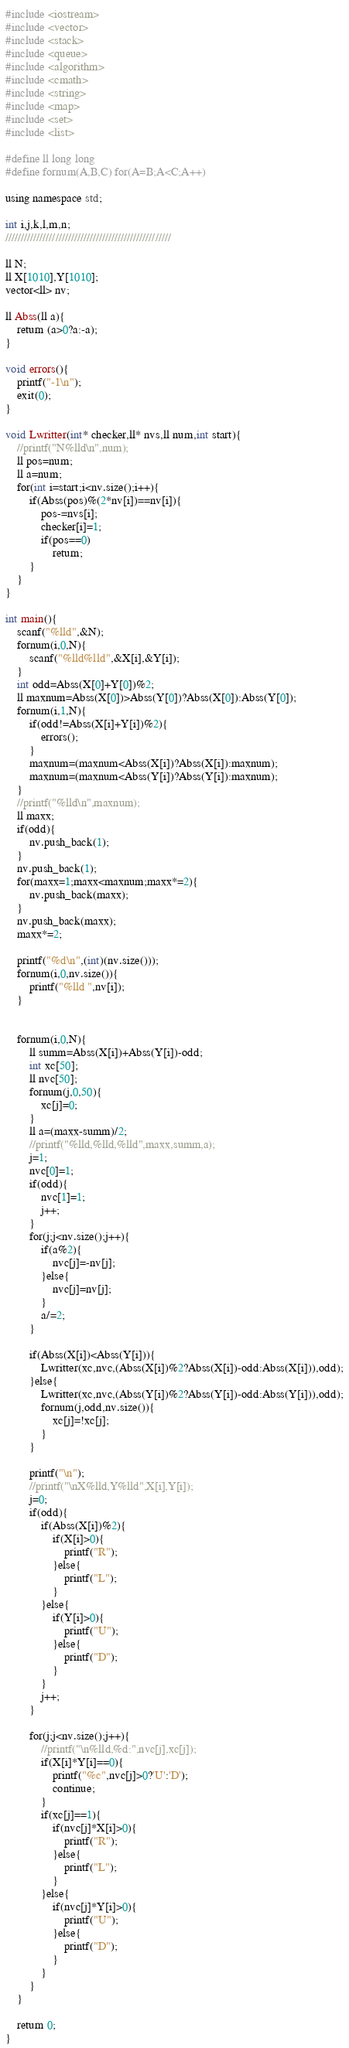<code> <loc_0><loc_0><loc_500><loc_500><_C++_>#include <iostream>
#include <vector>
#include <stack>
#include <queue>
#include <algorithm>
#include <cmath>
#include <string>
#include <map>
#include <set>
#include <list>

#define ll long long
#define fornum(A,B,C) for(A=B;A<C;A++)

using namespace std;

int i,j,k,l,m,n;
/////////////////////////////////////////////////////

ll N;
ll X[1010],Y[1010];
vector<ll> nv;

ll Abss(ll a){
    return (a>0?a:-a);
}

void errors(){
    printf("-1\n");
    exit(0);
}

void Lwritter(int* checker,ll* nvs,ll num,int start){
    //printf("N%lld\n",num);
    ll pos=num;
    ll a=num;
    for(int i=start;i<nv.size();i++){
        if(Abss(pos)%(2*nv[i])==nv[i]){
            pos-=nvs[i];
            checker[i]=1;
            if(pos==0)
                return;
        }
    }
}

int main(){
    scanf("%lld",&N);
    fornum(i,0,N){
        scanf("%lld%lld",&X[i],&Y[i]);
    }
    int odd=Abss(X[0]+Y[0])%2;
    ll maxnum=Abss(X[0])>Abss(Y[0])?Abss(X[0]):Abss(Y[0]);
    fornum(i,1,N){
        if(odd!=Abss(X[i]+Y[i])%2){
            errors();
        }
        maxnum=(maxnum<Abss(X[i])?Abss(X[i]):maxnum);
        maxnum=(maxnum<Abss(Y[i])?Abss(Y[i]):maxnum);
    }
    //printf("%lld\n",maxnum);
    ll maxx;
    if(odd){
        nv.push_back(1);
    }
    nv.push_back(1);
    for(maxx=1;maxx<maxnum;maxx*=2){
        nv.push_back(maxx);
    }
    nv.push_back(maxx);
    maxx*=2;

    printf("%d\n",(int)(nv.size()));
    fornum(i,0,nv.size()){
        printf("%lld ",nv[i]);
    }
    

    fornum(i,0,N){
        ll summ=Abss(X[i])+Abss(Y[i])-odd;
        int xc[50];
        ll nvc[50];
        fornum(j,0,50){
            xc[j]=0;
        }
        ll a=(maxx-summ)/2;
        //printf("%lld,%lld,%lld",maxx,summ,a);
        j=1;
        nvc[0]=1;
        if(odd){
            nvc[1]=1;
            j++;
        }
        for(j;j<nv.size();j++){
            if(a%2){
                nvc[j]=-nv[j];
            }else{
                nvc[j]=nv[j];
            }
            a/=2;
        }

        if(Abss(X[i])<Abss(Y[i])){
            Lwritter(xc,nvc,(Abss(X[i])%2?Abss(X[i])-odd:Abss(X[i])),odd);
        }else{
            Lwritter(xc,nvc,(Abss(Y[i])%2?Abss(Y[i])-odd:Abss(Y[i])),odd);
            fornum(j,odd,nv.size()){
                xc[j]=!xc[j];
            }
        }
        
        printf("\n");
        //printf("\nX%lld,Y%lld",X[i],Y[i]);
        j=0;
        if(odd){
            if(Abss(X[i])%2){
                if(X[i]>0){
                    printf("R");
                }else{
                    printf("L");
                }
            }else{
                if(Y[i]>0){
                    printf("U");
                }else{
                    printf("D");
                }
            }
            j++;
        }

        for(j;j<nv.size();j++){
            //printf("\n%lld,%d:",nvc[j],xc[j]);
            if(X[i]*Y[i]==0){
                printf("%c",nvc[j]>0?'U':'D');
                continue;
            }
            if(xc[j]==1){
                if(nvc[j]*X[i]>0){
                    printf("R");
                }else{
                    printf("L");
                }
            }else{
                if(nvc[j]*Y[i]>0){
                    printf("U");
                }else{
                    printf("D");
                }
            }
        }
    }

    return 0;
}</code> 